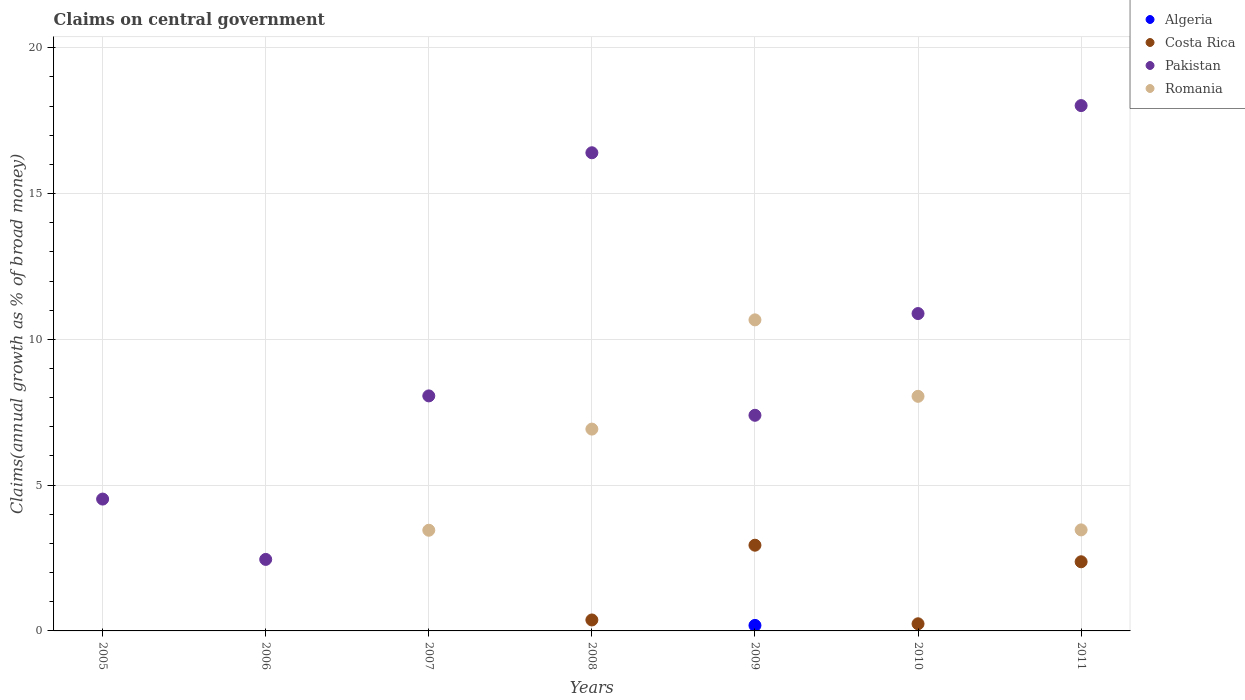How many different coloured dotlines are there?
Provide a short and direct response. 4. Is the number of dotlines equal to the number of legend labels?
Offer a very short reply. No. What is the percentage of broad money claimed on centeral government in Romania in 2009?
Provide a succinct answer. 10.67. Across all years, what is the maximum percentage of broad money claimed on centeral government in Pakistan?
Provide a succinct answer. 18.02. What is the total percentage of broad money claimed on centeral government in Pakistan in the graph?
Keep it short and to the point. 67.73. What is the difference between the percentage of broad money claimed on centeral government in Pakistan in 2007 and that in 2009?
Your response must be concise. 0.67. What is the difference between the percentage of broad money claimed on centeral government in Costa Rica in 2007 and the percentage of broad money claimed on centeral government in Pakistan in 2010?
Your response must be concise. -10.88. What is the average percentage of broad money claimed on centeral government in Pakistan per year?
Your answer should be compact. 9.68. In the year 2009, what is the difference between the percentage of broad money claimed on centeral government in Pakistan and percentage of broad money claimed on centeral government in Romania?
Give a very brief answer. -3.27. In how many years, is the percentage of broad money claimed on centeral government in Romania greater than 13 %?
Offer a terse response. 0. What is the ratio of the percentage of broad money claimed on centeral government in Pakistan in 2009 to that in 2011?
Provide a short and direct response. 0.41. Is the difference between the percentage of broad money claimed on centeral government in Pakistan in 2009 and 2011 greater than the difference between the percentage of broad money claimed on centeral government in Romania in 2009 and 2011?
Provide a succinct answer. No. What is the difference between the highest and the second highest percentage of broad money claimed on centeral government in Romania?
Give a very brief answer. 2.62. What is the difference between the highest and the lowest percentage of broad money claimed on centeral government in Pakistan?
Your answer should be very brief. 15.56. Is it the case that in every year, the sum of the percentage of broad money claimed on centeral government in Pakistan and percentage of broad money claimed on centeral government in Romania  is greater than the percentage of broad money claimed on centeral government in Algeria?
Keep it short and to the point. Yes. Does the percentage of broad money claimed on centeral government in Pakistan monotonically increase over the years?
Keep it short and to the point. No. Is the percentage of broad money claimed on centeral government in Pakistan strictly greater than the percentage of broad money claimed on centeral government in Romania over the years?
Offer a very short reply. No. Is the percentage of broad money claimed on centeral government in Algeria strictly less than the percentage of broad money claimed on centeral government in Pakistan over the years?
Offer a terse response. Yes. What is the difference between two consecutive major ticks on the Y-axis?
Make the answer very short. 5. Does the graph contain any zero values?
Provide a short and direct response. Yes. What is the title of the graph?
Your response must be concise. Claims on central government. What is the label or title of the Y-axis?
Your response must be concise. Claims(annual growth as % of broad money). What is the Claims(annual growth as % of broad money) in Pakistan in 2005?
Your answer should be very brief. 4.52. What is the Claims(annual growth as % of broad money) of Romania in 2005?
Give a very brief answer. 0. What is the Claims(annual growth as % of broad money) in Costa Rica in 2006?
Ensure brevity in your answer.  0. What is the Claims(annual growth as % of broad money) of Pakistan in 2006?
Make the answer very short. 2.45. What is the Claims(annual growth as % of broad money) in Costa Rica in 2007?
Your response must be concise. 0. What is the Claims(annual growth as % of broad money) of Pakistan in 2007?
Keep it short and to the point. 8.06. What is the Claims(annual growth as % of broad money) in Romania in 2007?
Keep it short and to the point. 3.45. What is the Claims(annual growth as % of broad money) in Algeria in 2008?
Give a very brief answer. 0. What is the Claims(annual growth as % of broad money) of Costa Rica in 2008?
Keep it short and to the point. 0.38. What is the Claims(annual growth as % of broad money) in Pakistan in 2008?
Ensure brevity in your answer.  16.4. What is the Claims(annual growth as % of broad money) in Romania in 2008?
Make the answer very short. 6.92. What is the Claims(annual growth as % of broad money) in Algeria in 2009?
Offer a terse response. 0.19. What is the Claims(annual growth as % of broad money) of Costa Rica in 2009?
Offer a terse response. 2.94. What is the Claims(annual growth as % of broad money) of Pakistan in 2009?
Make the answer very short. 7.4. What is the Claims(annual growth as % of broad money) of Romania in 2009?
Make the answer very short. 10.67. What is the Claims(annual growth as % of broad money) of Algeria in 2010?
Offer a very short reply. 0. What is the Claims(annual growth as % of broad money) in Costa Rica in 2010?
Keep it short and to the point. 0.24. What is the Claims(annual growth as % of broad money) in Pakistan in 2010?
Your answer should be compact. 10.88. What is the Claims(annual growth as % of broad money) in Romania in 2010?
Make the answer very short. 8.05. What is the Claims(annual growth as % of broad money) in Costa Rica in 2011?
Your answer should be very brief. 2.37. What is the Claims(annual growth as % of broad money) in Pakistan in 2011?
Make the answer very short. 18.02. What is the Claims(annual growth as % of broad money) of Romania in 2011?
Provide a succinct answer. 3.47. Across all years, what is the maximum Claims(annual growth as % of broad money) in Algeria?
Your answer should be compact. 0.19. Across all years, what is the maximum Claims(annual growth as % of broad money) in Costa Rica?
Your answer should be compact. 2.94. Across all years, what is the maximum Claims(annual growth as % of broad money) in Pakistan?
Give a very brief answer. 18.02. Across all years, what is the maximum Claims(annual growth as % of broad money) in Romania?
Offer a very short reply. 10.67. Across all years, what is the minimum Claims(annual growth as % of broad money) in Algeria?
Make the answer very short. 0. Across all years, what is the minimum Claims(annual growth as % of broad money) in Costa Rica?
Keep it short and to the point. 0. Across all years, what is the minimum Claims(annual growth as % of broad money) of Pakistan?
Provide a short and direct response. 2.45. What is the total Claims(annual growth as % of broad money) in Algeria in the graph?
Your answer should be very brief. 0.19. What is the total Claims(annual growth as % of broad money) in Costa Rica in the graph?
Keep it short and to the point. 5.93. What is the total Claims(annual growth as % of broad money) in Pakistan in the graph?
Offer a terse response. 67.73. What is the total Claims(annual growth as % of broad money) in Romania in the graph?
Give a very brief answer. 32.55. What is the difference between the Claims(annual growth as % of broad money) in Pakistan in 2005 and that in 2006?
Your answer should be compact. 2.07. What is the difference between the Claims(annual growth as % of broad money) of Pakistan in 2005 and that in 2007?
Ensure brevity in your answer.  -3.54. What is the difference between the Claims(annual growth as % of broad money) of Pakistan in 2005 and that in 2008?
Your answer should be compact. -11.88. What is the difference between the Claims(annual growth as % of broad money) of Pakistan in 2005 and that in 2009?
Your response must be concise. -2.87. What is the difference between the Claims(annual growth as % of broad money) of Pakistan in 2005 and that in 2010?
Offer a very short reply. -6.36. What is the difference between the Claims(annual growth as % of broad money) in Pakistan in 2005 and that in 2011?
Keep it short and to the point. -13.5. What is the difference between the Claims(annual growth as % of broad money) in Pakistan in 2006 and that in 2007?
Offer a terse response. -5.61. What is the difference between the Claims(annual growth as % of broad money) of Pakistan in 2006 and that in 2008?
Give a very brief answer. -13.95. What is the difference between the Claims(annual growth as % of broad money) of Pakistan in 2006 and that in 2009?
Give a very brief answer. -4.94. What is the difference between the Claims(annual growth as % of broad money) in Pakistan in 2006 and that in 2010?
Ensure brevity in your answer.  -8.43. What is the difference between the Claims(annual growth as % of broad money) in Pakistan in 2006 and that in 2011?
Provide a short and direct response. -15.56. What is the difference between the Claims(annual growth as % of broad money) in Pakistan in 2007 and that in 2008?
Ensure brevity in your answer.  -8.34. What is the difference between the Claims(annual growth as % of broad money) of Romania in 2007 and that in 2008?
Offer a very short reply. -3.47. What is the difference between the Claims(annual growth as % of broad money) of Pakistan in 2007 and that in 2009?
Ensure brevity in your answer.  0.67. What is the difference between the Claims(annual growth as % of broad money) in Romania in 2007 and that in 2009?
Provide a short and direct response. -7.22. What is the difference between the Claims(annual growth as % of broad money) in Pakistan in 2007 and that in 2010?
Give a very brief answer. -2.82. What is the difference between the Claims(annual growth as % of broad money) of Romania in 2007 and that in 2010?
Your answer should be very brief. -4.59. What is the difference between the Claims(annual growth as % of broad money) of Pakistan in 2007 and that in 2011?
Offer a very short reply. -9.96. What is the difference between the Claims(annual growth as % of broad money) of Romania in 2007 and that in 2011?
Provide a succinct answer. -0.01. What is the difference between the Claims(annual growth as % of broad money) in Costa Rica in 2008 and that in 2009?
Your answer should be very brief. -2.56. What is the difference between the Claims(annual growth as % of broad money) of Pakistan in 2008 and that in 2009?
Keep it short and to the point. 9. What is the difference between the Claims(annual growth as % of broad money) of Romania in 2008 and that in 2009?
Ensure brevity in your answer.  -3.75. What is the difference between the Claims(annual growth as % of broad money) of Costa Rica in 2008 and that in 2010?
Your response must be concise. 0.13. What is the difference between the Claims(annual growth as % of broad money) of Pakistan in 2008 and that in 2010?
Offer a very short reply. 5.51. What is the difference between the Claims(annual growth as % of broad money) in Romania in 2008 and that in 2010?
Offer a very short reply. -1.12. What is the difference between the Claims(annual growth as % of broad money) in Costa Rica in 2008 and that in 2011?
Offer a very short reply. -2. What is the difference between the Claims(annual growth as % of broad money) of Pakistan in 2008 and that in 2011?
Provide a succinct answer. -1.62. What is the difference between the Claims(annual growth as % of broad money) of Romania in 2008 and that in 2011?
Offer a terse response. 3.46. What is the difference between the Claims(annual growth as % of broad money) of Costa Rica in 2009 and that in 2010?
Make the answer very short. 2.7. What is the difference between the Claims(annual growth as % of broad money) in Pakistan in 2009 and that in 2010?
Provide a succinct answer. -3.49. What is the difference between the Claims(annual growth as % of broad money) of Romania in 2009 and that in 2010?
Your answer should be very brief. 2.62. What is the difference between the Claims(annual growth as % of broad money) of Costa Rica in 2009 and that in 2011?
Make the answer very short. 0.57. What is the difference between the Claims(annual growth as % of broad money) of Pakistan in 2009 and that in 2011?
Make the answer very short. -10.62. What is the difference between the Claims(annual growth as % of broad money) of Romania in 2009 and that in 2011?
Keep it short and to the point. 7.2. What is the difference between the Claims(annual growth as % of broad money) of Costa Rica in 2010 and that in 2011?
Give a very brief answer. -2.13. What is the difference between the Claims(annual growth as % of broad money) in Pakistan in 2010 and that in 2011?
Offer a terse response. -7.13. What is the difference between the Claims(annual growth as % of broad money) of Romania in 2010 and that in 2011?
Ensure brevity in your answer.  4.58. What is the difference between the Claims(annual growth as % of broad money) of Pakistan in 2005 and the Claims(annual growth as % of broad money) of Romania in 2007?
Offer a terse response. 1.07. What is the difference between the Claims(annual growth as % of broad money) in Pakistan in 2005 and the Claims(annual growth as % of broad money) in Romania in 2008?
Give a very brief answer. -2.4. What is the difference between the Claims(annual growth as % of broad money) in Pakistan in 2005 and the Claims(annual growth as % of broad money) in Romania in 2009?
Provide a short and direct response. -6.15. What is the difference between the Claims(annual growth as % of broad money) in Pakistan in 2005 and the Claims(annual growth as % of broad money) in Romania in 2010?
Provide a short and direct response. -3.52. What is the difference between the Claims(annual growth as % of broad money) in Pakistan in 2005 and the Claims(annual growth as % of broad money) in Romania in 2011?
Give a very brief answer. 1.06. What is the difference between the Claims(annual growth as % of broad money) of Pakistan in 2006 and the Claims(annual growth as % of broad money) of Romania in 2007?
Your response must be concise. -1. What is the difference between the Claims(annual growth as % of broad money) in Pakistan in 2006 and the Claims(annual growth as % of broad money) in Romania in 2008?
Your answer should be compact. -4.47. What is the difference between the Claims(annual growth as % of broad money) in Pakistan in 2006 and the Claims(annual growth as % of broad money) in Romania in 2009?
Your answer should be compact. -8.22. What is the difference between the Claims(annual growth as % of broad money) in Pakistan in 2006 and the Claims(annual growth as % of broad money) in Romania in 2010?
Your answer should be compact. -5.59. What is the difference between the Claims(annual growth as % of broad money) in Pakistan in 2006 and the Claims(annual growth as % of broad money) in Romania in 2011?
Your answer should be compact. -1.01. What is the difference between the Claims(annual growth as % of broad money) of Pakistan in 2007 and the Claims(annual growth as % of broad money) of Romania in 2008?
Keep it short and to the point. 1.14. What is the difference between the Claims(annual growth as % of broad money) in Pakistan in 2007 and the Claims(annual growth as % of broad money) in Romania in 2009?
Make the answer very short. -2.61. What is the difference between the Claims(annual growth as % of broad money) in Pakistan in 2007 and the Claims(annual growth as % of broad money) in Romania in 2010?
Give a very brief answer. 0.01. What is the difference between the Claims(annual growth as % of broad money) of Pakistan in 2007 and the Claims(annual growth as % of broad money) of Romania in 2011?
Ensure brevity in your answer.  4.6. What is the difference between the Claims(annual growth as % of broad money) in Costa Rica in 2008 and the Claims(annual growth as % of broad money) in Pakistan in 2009?
Keep it short and to the point. -7.02. What is the difference between the Claims(annual growth as % of broad money) in Costa Rica in 2008 and the Claims(annual growth as % of broad money) in Romania in 2009?
Make the answer very short. -10.29. What is the difference between the Claims(annual growth as % of broad money) in Pakistan in 2008 and the Claims(annual growth as % of broad money) in Romania in 2009?
Offer a very short reply. 5.73. What is the difference between the Claims(annual growth as % of broad money) in Costa Rica in 2008 and the Claims(annual growth as % of broad money) in Pakistan in 2010?
Ensure brevity in your answer.  -10.51. What is the difference between the Claims(annual growth as % of broad money) in Costa Rica in 2008 and the Claims(annual growth as % of broad money) in Romania in 2010?
Make the answer very short. -7.67. What is the difference between the Claims(annual growth as % of broad money) of Pakistan in 2008 and the Claims(annual growth as % of broad money) of Romania in 2010?
Offer a terse response. 8.35. What is the difference between the Claims(annual growth as % of broad money) of Costa Rica in 2008 and the Claims(annual growth as % of broad money) of Pakistan in 2011?
Offer a very short reply. -17.64. What is the difference between the Claims(annual growth as % of broad money) of Costa Rica in 2008 and the Claims(annual growth as % of broad money) of Romania in 2011?
Offer a terse response. -3.09. What is the difference between the Claims(annual growth as % of broad money) of Pakistan in 2008 and the Claims(annual growth as % of broad money) of Romania in 2011?
Your answer should be very brief. 12.93. What is the difference between the Claims(annual growth as % of broad money) in Algeria in 2009 and the Claims(annual growth as % of broad money) in Costa Rica in 2010?
Your response must be concise. -0.06. What is the difference between the Claims(annual growth as % of broad money) in Algeria in 2009 and the Claims(annual growth as % of broad money) in Pakistan in 2010?
Provide a short and direct response. -10.7. What is the difference between the Claims(annual growth as % of broad money) of Algeria in 2009 and the Claims(annual growth as % of broad money) of Romania in 2010?
Your answer should be compact. -7.86. What is the difference between the Claims(annual growth as % of broad money) of Costa Rica in 2009 and the Claims(annual growth as % of broad money) of Pakistan in 2010?
Your answer should be very brief. -7.94. What is the difference between the Claims(annual growth as % of broad money) of Costa Rica in 2009 and the Claims(annual growth as % of broad money) of Romania in 2010?
Give a very brief answer. -5.11. What is the difference between the Claims(annual growth as % of broad money) in Pakistan in 2009 and the Claims(annual growth as % of broad money) in Romania in 2010?
Give a very brief answer. -0.65. What is the difference between the Claims(annual growth as % of broad money) in Algeria in 2009 and the Claims(annual growth as % of broad money) in Costa Rica in 2011?
Keep it short and to the point. -2.18. What is the difference between the Claims(annual growth as % of broad money) in Algeria in 2009 and the Claims(annual growth as % of broad money) in Pakistan in 2011?
Your response must be concise. -17.83. What is the difference between the Claims(annual growth as % of broad money) in Algeria in 2009 and the Claims(annual growth as % of broad money) in Romania in 2011?
Offer a very short reply. -3.28. What is the difference between the Claims(annual growth as % of broad money) in Costa Rica in 2009 and the Claims(annual growth as % of broad money) in Pakistan in 2011?
Ensure brevity in your answer.  -15.08. What is the difference between the Claims(annual growth as % of broad money) in Costa Rica in 2009 and the Claims(annual growth as % of broad money) in Romania in 2011?
Your answer should be very brief. -0.53. What is the difference between the Claims(annual growth as % of broad money) in Pakistan in 2009 and the Claims(annual growth as % of broad money) in Romania in 2011?
Your answer should be very brief. 3.93. What is the difference between the Claims(annual growth as % of broad money) in Costa Rica in 2010 and the Claims(annual growth as % of broad money) in Pakistan in 2011?
Provide a short and direct response. -17.77. What is the difference between the Claims(annual growth as % of broad money) of Costa Rica in 2010 and the Claims(annual growth as % of broad money) of Romania in 2011?
Your answer should be compact. -3.22. What is the difference between the Claims(annual growth as % of broad money) of Pakistan in 2010 and the Claims(annual growth as % of broad money) of Romania in 2011?
Your answer should be very brief. 7.42. What is the average Claims(annual growth as % of broad money) of Algeria per year?
Your answer should be compact. 0.03. What is the average Claims(annual growth as % of broad money) of Costa Rica per year?
Your answer should be very brief. 0.85. What is the average Claims(annual growth as % of broad money) in Pakistan per year?
Give a very brief answer. 9.68. What is the average Claims(annual growth as % of broad money) in Romania per year?
Your response must be concise. 4.65. In the year 2007, what is the difference between the Claims(annual growth as % of broad money) of Pakistan and Claims(annual growth as % of broad money) of Romania?
Offer a very short reply. 4.61. In the year 2008, what is the difference between the Claims(annual growth as % of broad money) in Costa Rica and Claims(annual growth as % of broad money) in Pakistan?
Your answer should be compact. -16.02. In the year 2008, what is the difference between the Claims(annual growth as % of broad money) in Costa Rica and Claims(annual growth as % of broad money) in Romania?
Provide a succinct answer. -6.55. In the year 2008, what is the difference between the Claims(annual growth as % of broad money) in Pakistan and Claims(annual growth as % of broad money) in Romania?
Give a very brief answer. 9.48. In the year 2009, what is the difference between the Claims(annual growth as % of broad money) in Algeria and Claims(annual growth as % of broad money) in Costa Rica?
Your answer should be compact. -2.75. In the year 2009, what is the difference between the Claims(annual growth as % of broad money) in Algeria and Claims(annual growth as % of broad money) in Pakistan?
Your response must be concise. -7.21. In the year 2009, what is the difference between the Claims(annual growth as % of broad money) of Algeria and Claims(annual growth as % of broad money) of Romania?
Your answer should be compact. -10.48. In the year 2009, what is the difference between the Claims(annual growth as % of broad money) in Costa Rica and Claims(annual growth as % of broad money) in Pakistan?
Your answer should be compact. -4.46. In the year 2009, what is the difference between the Claims(annual growth as % of broad money) in Costa Rica and Claims(annual growth as % of broad money) in Romania?
Keep it short and to the point. -7.73. In the year 2009, what is the difference between the Claims(annual growth as % of broad money) of Pakistan and Claims(annual growth as % of broad money) of Romania?
Your response must be concise. -3.27. In the year 2010, what is the difference between the Claims(annual growth as % of broad money) of Costa Rica and Claims(annual growth as % of broad money) of Pakistan?
Offer a very short reply. -10.64. In the year 2010, what is the difference between the Claims(annual growth as % of broad money) in Costa Rica and Claims(annual growth as % of broad money) in Romania?
Your response must be concise. -7.8. In the year 2010, what is the difference between the Claims(annual growth as % of broad money) in Pakistan and Claims(annual growth as % of broad money) in Romania?
Keep it short and to the point. 2.84. In the year 2011, what is the difference between the Claims(annual growth as % of broad money) in Costa Rica and Claims(annual growth as % of broad money) in Pakistan?
Offer a terse response. -15.65. In the year 2011, what is the difference between the Claims(annual growth as % of broad money) in Costa Rica and Claims(annual growth as % of broad money) in Romania?
Offer a terse response. -1.09. In the year 2011, what is the difference between the Claims(annual growth as % of broad money) of Pakistan and Claims(annual growth as % of broad money) of Romania?
Keep it short and to the point. 14.55. What is the ratio of the Claims(annual growth as % of broad money) in Pakistan in 2005 to that in 2006?
Your answer should be compact. 1.84. What is the ratio of the Claims(annual growth as % of broad money) of Pakistan in 2005 to that in 2007?
Your answer should be compact. 0.56. What is the ratio of the Claims(annual growth as % of broad money) in Pakistan in 2005 to that in 2008?
Your answer should be very brief. 0.28. What is the ratio of the Claims(annual growth as % of broad money) of Pakistan in 2005 to that in 2009?
Make the answer very short. 0.61. What is the ratio of the Claims(annual growth as % of broad money) of Pakistan in 2005 to that in 2010?
Provide a succinct answer. 0.42. What is the ratio of the Claims(annual growth as % of broad money) of Pakistan in 2005 to that in 2011?
Offer a very short reply. 0.25. What is the ratio of the Claims(annual growth as % of broad money) of Pakistan in 2006 to that in 2007?
Make the answer very short. 0.3. What is the ratio of the Claims(annual growth as % of broad money) in Pakistan in 2006 to that in 2008?
Offer a very short reply. 0.15. What is the ratio of the Claims(annual growth as % of broad money) of Pakistan in 2006 to that in 2009?
Your answer should be compact. 0.33. What is the ratio of the Claims(annual growth as % of broad money) of Pakistan in 2006 to that in 2010?
Provide a succinct answer. 0.23. What is the ratio of the Claims(annual growth as % of broad money) in Pakistan in 2006 to that in 2011?
Make the answer very short. 0.14. What is the ratio of the Claims(annual growth as % of broad money) in Pakistan in 2007 to that in 2008?
Offer a terse response. 0.49. What is the ratio of the Claims(annual growth as % of broad money) of Romania in 2007 to that in 2008?
Ensure brevity in your answer.  0.5. What is the ratio of the Claims(annual growth as % of broad money) of Pakistan in 2007 to that in 2009?
Offer a very short reply. 1.09. What is the ratio of the Claims(annual growth as % of broad money) in Romania in 2007 to that in 2009?
Keep it short and to the point. 0.32. What is the ratio of the Claims(annual growth as % of broad money) in Pakistan in 2007 to that in 2010?
Your response must be concise. 0.74. What is the ratio of the Claims(annual growth as % of broad money) of Romania in 2007 to that in 2010?
Offer a very short reply. 0.43. What is the ratio of the Claims(annual growth as % of broad money) of Pakistan in 2007 to that in 2011?
Provide a short and direct response. 0.45. What is the ratio of the Claims(annual growth as % of broad money) in Costa Rica in 2008 to that in 2009?
Offer a very short reply. 0.13. What is the ratio of the Claims(annual growth as % of broad money) of Pakistan in 2008 to that in 2009?
Ensure brevity in your answer.  2.22. What is the ratio of the Claims(annual growth as % of broad money) of Romania in 2008 to that in 2009?
Give a very brief answer. 0.65. What is the ratio of the Claims(annual growth as % of broad money) of Costa Rica in 2008 to that in 2010?
Offer a very short reply. 1.54. What is the ratio of the Claims(annual growth as % of broad money) in Pakistan in 2008 to that in 2010?
Keep it short and to the point. 1.51. What is the ratio of the Claims(annual growth as % of broad money) in Romania in 2008 to that in 2010?
Provide a succinct answer. 0.86. What is the ratio of the Claims(annual growth as % of broad money) of Costa Rica in 2008 to that in 2011?
Give a very brief answer. 0.16. What is the ratio of the Claims(annual growth as % of broad money) of Pakistan in 2008 to that in 2011?
Give a very brief answer. 0.91. What is the ratio of the Claims(annual growth as % of broad money) of Romania in 2008 to that in 2011?
Keep it short and to the point. 2. What is the ratio of the Claims(annual growth as % of broad money) in Costa Rica in 2009 to that in 2010?
Give a very brief answer. 12.02. What is the ratio of the Claims(annual growth as % of broad money) of Pakistan in 2009 to that in 2010?
Your answer should be compact. 0.68. What is the ratio of the Claims(annual growth as % of broad money) in Romania in 2009 to that in 2010?
Provide a short and direct response. 1.33. What is the ratio of the Claims(annual growth as % of broad money) in Costa Rica in 2009 to that in 2011?
Your answer should be very brief. 1.24. What is the ratio of the Claims(annual growth as % of broad money) of Pakistan in 2009 to that in 2011?
Offer a very short reply. 0.41. What is the ratio of the Claims(annual growth as % of broad money) of Romania in 2009 to that in 2011?
Your response must be concise. 3.08. What is the ratio of the Claims(annual growth as % of broad money) of Costa Rica in 2010 to that in 2011?
Make the answer very short. 0.1. What is the ratio of the Claims(annual growth as % of broad money) of Pakistan in 2010 to that in 2011?
Your response must be concise. 0.6. What is the ratio of the Claims(annual growth as % of broad money) in Romania in 2010 to that in 2011?
Your answer should be very brief. 2.32. What is the difference between the highest and the second highest Claims(annual growth as % of broad money) in Costa Rica?
Ensure brevity in your answer.  0.57. What is the difference between the highest and the second highest Claims(annual growth as % of broad money) in Pakistan?
Offer a very short reply. 1.62. What is the difference between the highest and the second highest Claims(annual growth as % of broad money) in Romania?
Your answer should be compact. 2.62. What is the difference between the highest and the lowest Claims(annual growth as % of broad money) of Algeria?
Make the answer very short. 0.19. What is the difference between the highest and the lowest Claims(annual growth as % of broad money) of Costa Rica?
Your answer should be very brief. 2.94. What is the difference between the highest and the lowest Claims(annual growth as % of broad money) in Pakistan?
Your response must be concise. 15.56. What is the difference between the highest and the lowest Claims(annual growth as % of broad money) of Romania?
Offer a terse response. 10.67. 